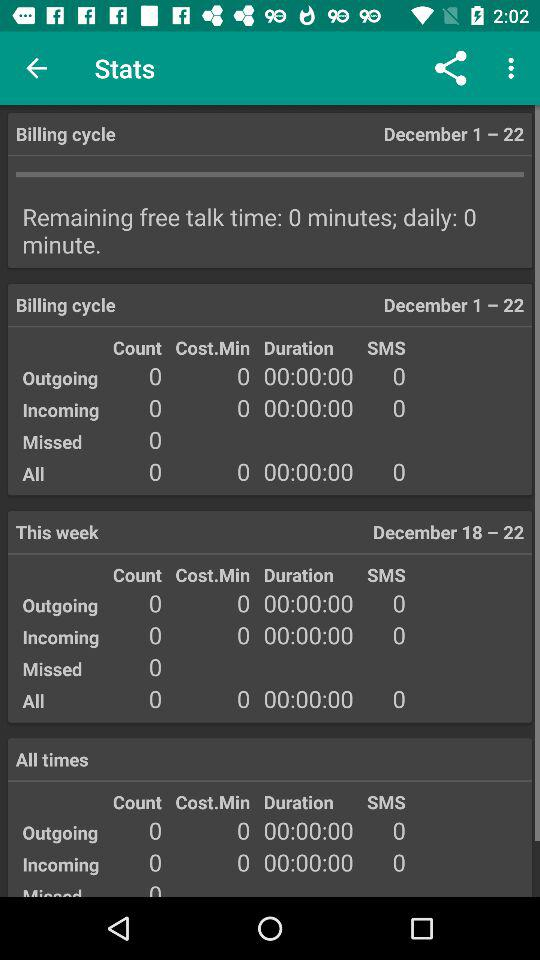What is the duration of all calls from December 1st to December 22nd? The duration of all calls from December 1st to December 22nd is 0 hours 0 minutes 0 seconds. 